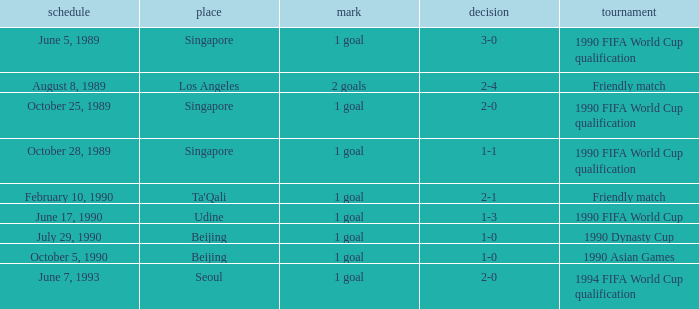What was the score of the match with a 3-0 result? 1 goal. 